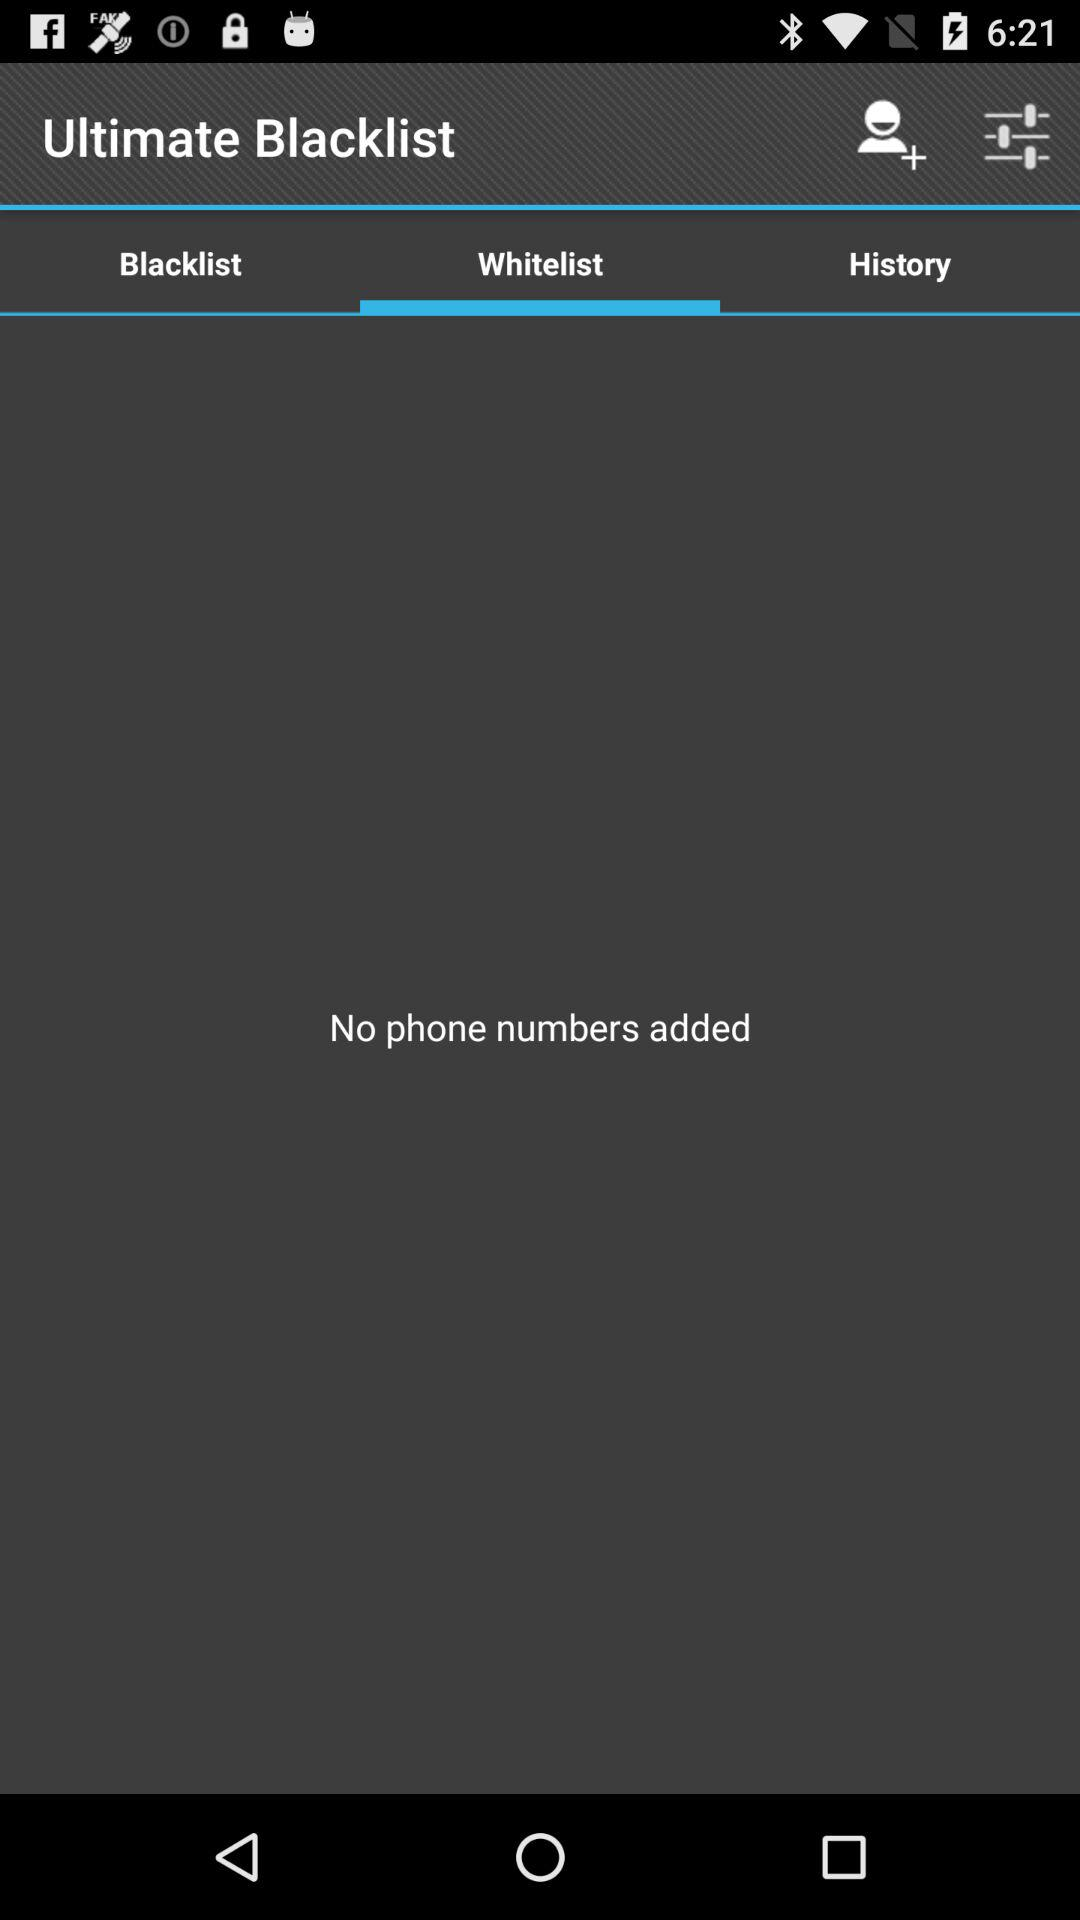Which tab is selected for the ultimate blacklist? The selected tab is whitelist. 